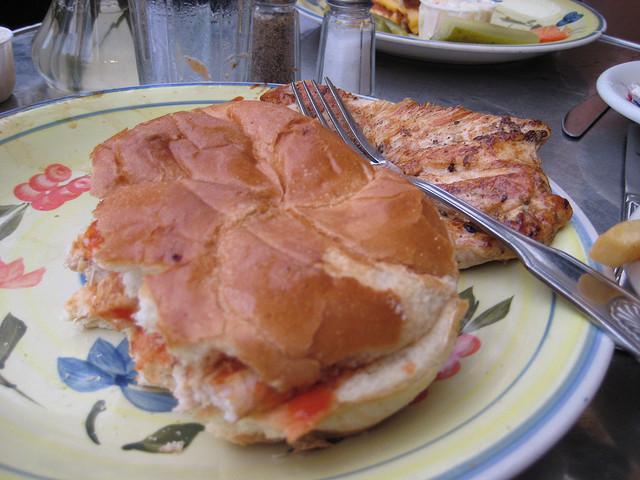What is to the right of the bun?
Keep it brief. Fork. What is the Protein?
Be succinct. Chicken. What type of design is on the plate?
Quick response, please. Flowers. 